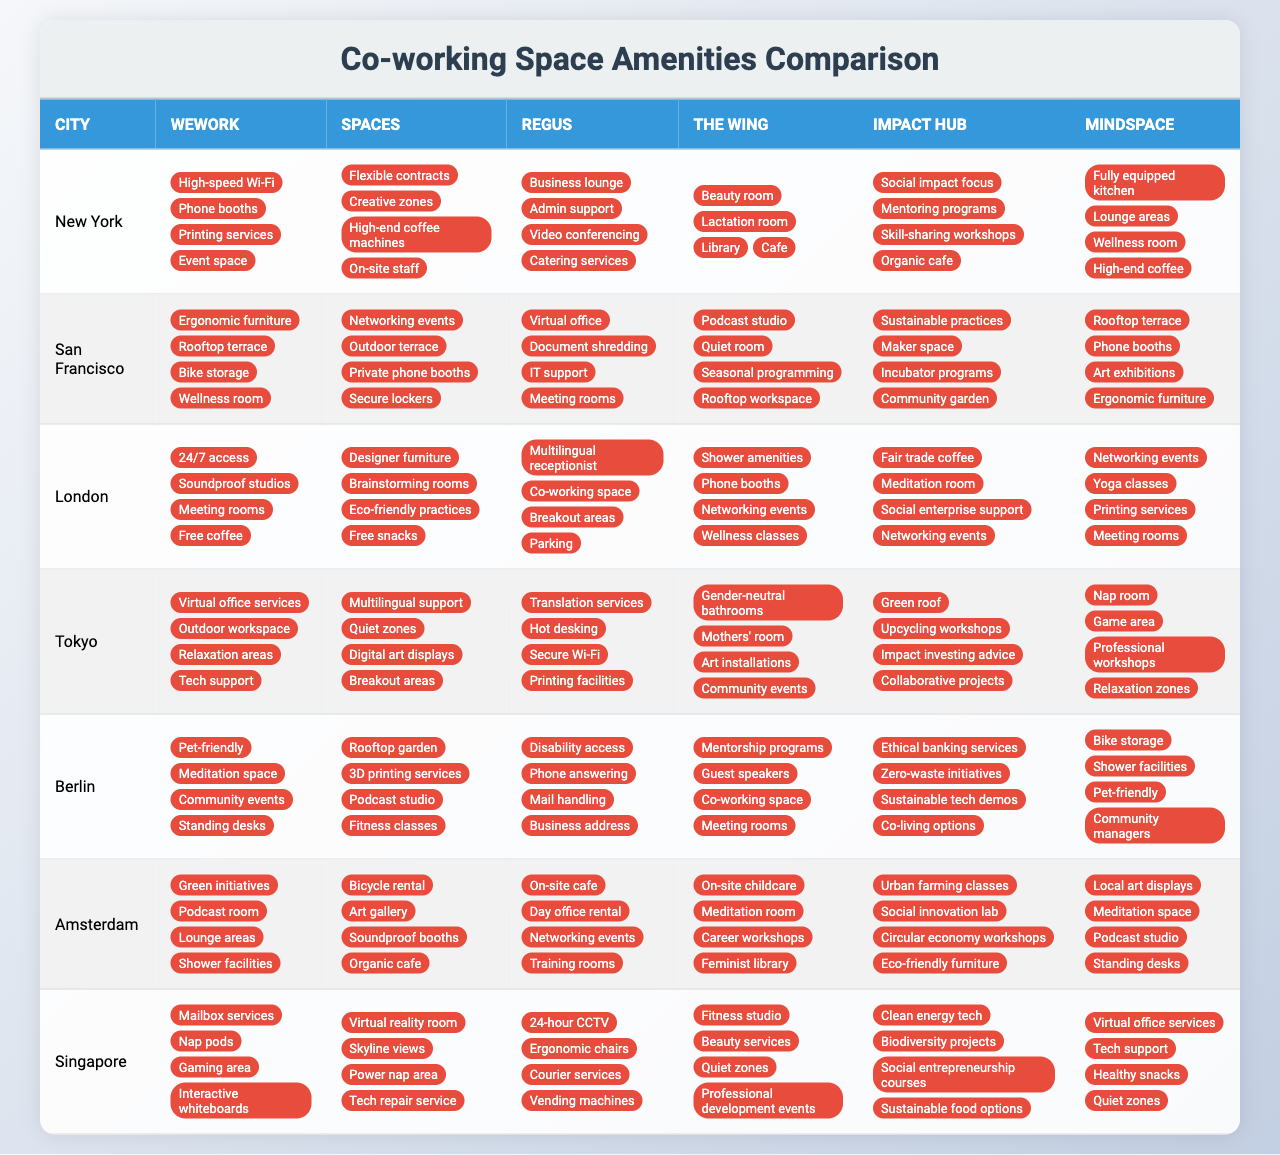What amenities are available in co-working spaces in Tokyo? In Tokyo, the amenities offered by WeWork include virtual office services, outdoor workspace, relaxation areas, and tech support. Spaces provides multilingual support, quiet zones, digital art displays, and breakout areas. Regus offers translation services, hot desking, secure Wi-Fi, and printing facilities. The Wing includes gender-neutral bathrooms, a mothers' room, art installations, and community events. Impact Hub features a green roof, upcycling workshops, impact investing advice, and collaborative projects. Mindspace provides a nap room, game area, professional workshops, and relaxation zones.
Answer: Virtual office services, outdoor workspace, relaxation areas, tech support, multilingual support, quiet zones, digital art displays, breakout areas, translation services, hot desking, secure Wi-Fi, printing facilities, gender-neutral bathrooms, mothers' room, art installations, community events, green roof, upcycling workshops, impact investing advice, collaborative projects, nap room, game area, professional workshops, relaxation zones Which city has the most unique features across different co-working spaces? To determine this, I would compare the specific amenities across all cities. Amsterdam and Singapore both have features like a virtual reality room and skyline views in Singapore, as well as an art gallery and organic cafe in Amsterdam. However, Singapore's unique offerings like clean energy tech and biodiversity projects stand out. Hence, I identify Singapore to have a wider range of unique amenities across the spaces.
Answer: Singapore Are there any co-working spaces that provide 24/7 access? Looking at the amenities in the table, WeWork offers 24/7 access in London and Regus does in Singapore. Therefore, both companies provide this amenity.
Answer: Yes Which company provides the most specific community-focused amenities? Analyzing the amenities, Impact Hub features social impact focus, mentoring programs, skill-sharing workshops, and organic cafe, which clearly align with community engagement and sustainability. This suggests a strong focus on community in their offerings, more than other companies listed.
Answer: Impact Hub What is the average number of unique amenities provided by each company in New York? By counting the unique amenities offered by each company in New York: WeWork has 4, Spaces has 4, Regus has 4, The Wing has 4, Impact Hub has 4, and Mindspace has 4, making it a total of 24 amenities across 6 companies. Dividing gives an average of 24/6 = 4.
Answer: 4 Is there a space that specifically caters to parents? The Wing provides a lactation room and on-site childcare, highlighting its amenities aimed at parents. Other spaces do not mention child-oriented facilities. Therefore, The Wing is the only one that explicitly caters to parents.
Answer: Yes How many spaces in London offer soundproof studios? Looking at the London row, WeWork has soundproof studios, while Spaces offers designer furniture and impact-focused amenities. Therefore, only WeWork in London specifically mentions soundproof studios as an amenity.
Answer: 1 